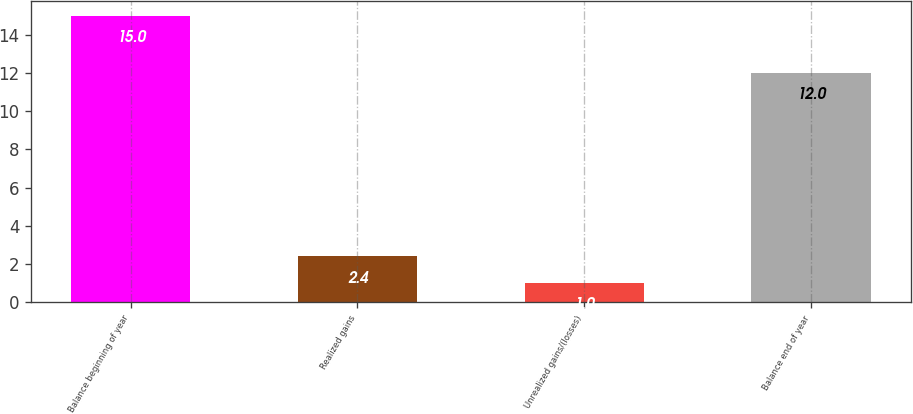Convert chart. <chart><loc_0><loc_0><loc_500><loc_500><bar_chart><fcel>Balance beginning of year<fcel>Realized gains<fcel>Unrealized gains/(losses)<fcel>Balance end of year<nl><fcel>15<fcel>2.4<fcel>1<fcel>12<nl></chart> 